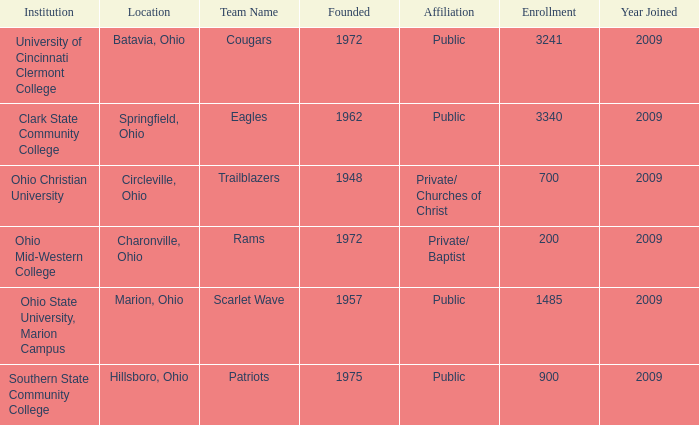What is the site for the team name of eagles? Springfield, Ohio. 